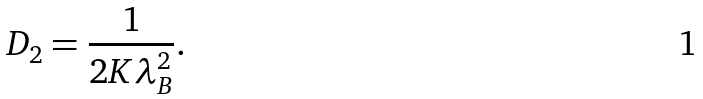<formula> <loc_0><loc_0><loc_500><loc_500>D _ { 2 } = \frac { 1 } { 2 K \lambda _ { B } ^ { 2 } } .</formula> 